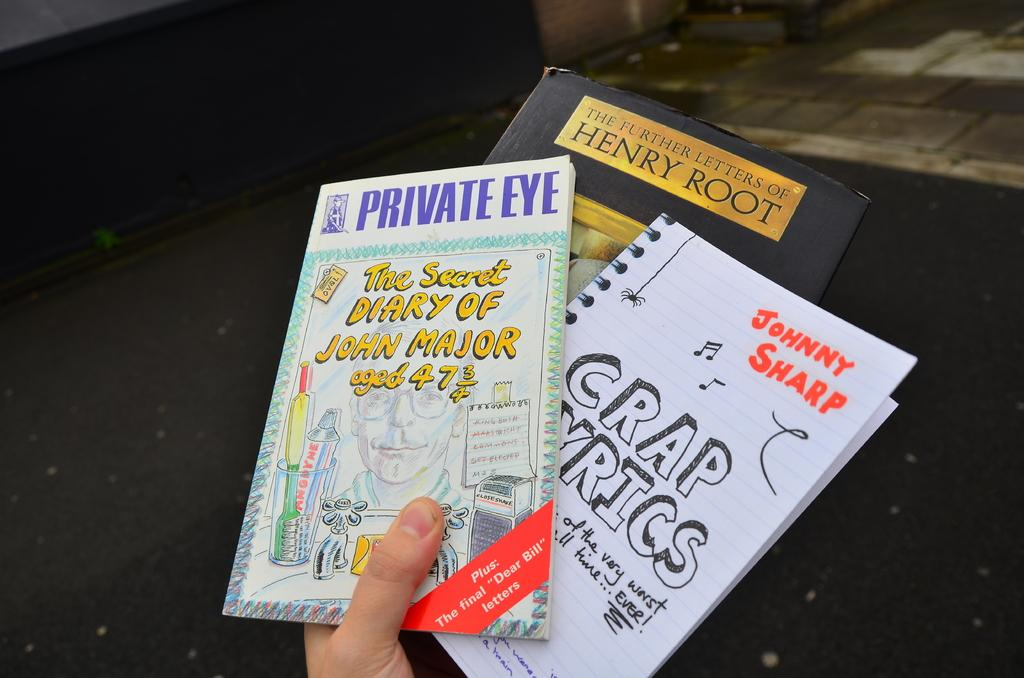<image>
Create a compact narrative representing the image presented. A hand holds up three books including Private Eye, Johnny Sharp, and The Further Letters of Henry Root. 